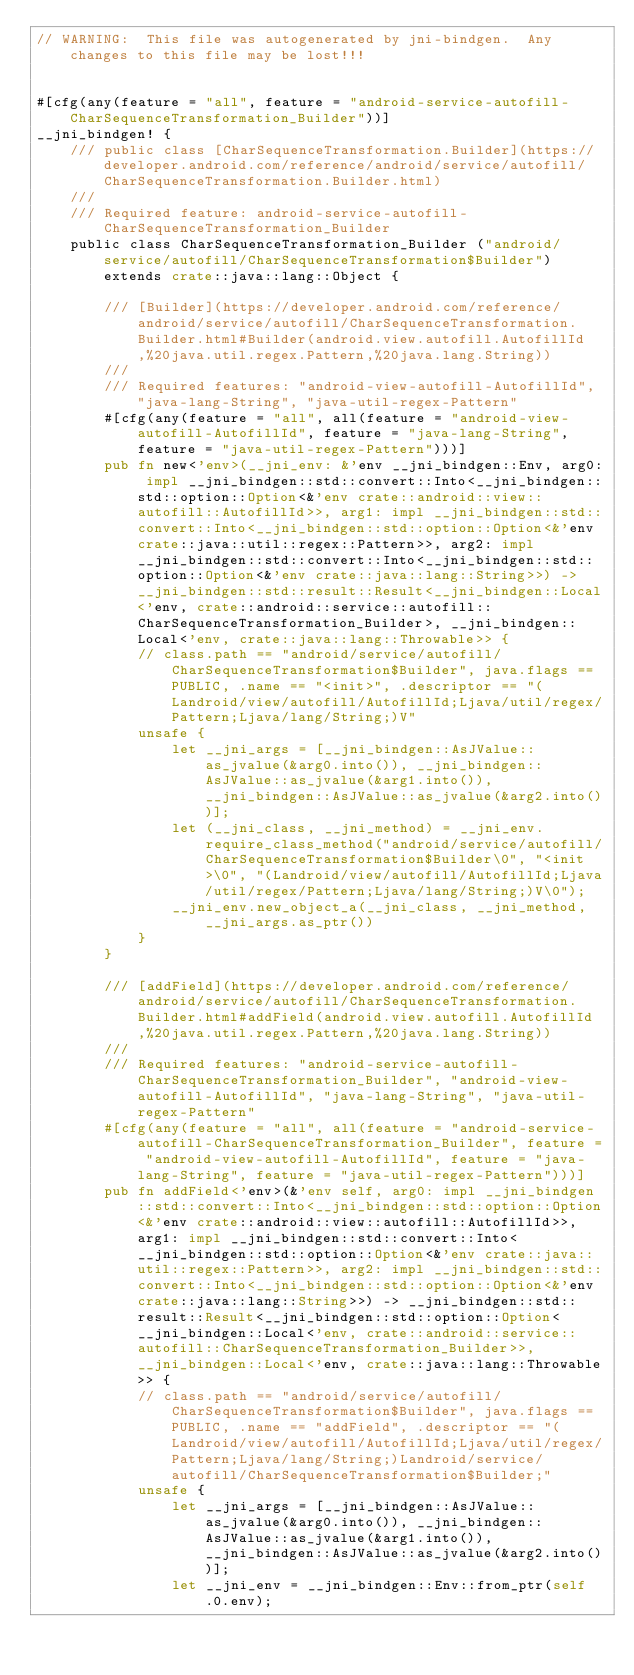<code> <loc_0><loc_0><loc_500><loc_500><_Rust_>// WARNING:  This file was autogenerated by jni-bindgen.  Any changes to this file may be lost!!!


#[cfg(any(feature = "all", feature = "android-service-autofill-CharSequenceTransformation_Builder"))]
__jni_bindgen! {
    /// public class [CharSequenceTransformation.Builder](https://developer.android.com/reference/android/service/autofill/CharSequenceTransformation.Builder.html)
    ///
    /// Required feature: android-service-autofill-CharSequenceTransformation_Builder
    public class CharSequenceTransformation_Builder ("android/service/autofill/CharSequenceTransformation$Builder") extends crate::java::lang::Object {

        /// [Builder](https://developer.android.com/reference/android/service/autofill/CharSequenceTransformation.Builder.html#Builder(android.view.autofill.AutofillId,%20java.util.regex.Pattern,%20java.lang.String))
        ///
        /// Required features: "android-view-autofill-AutofillId", "java-lang-String", "java-util-regex-Pattern"
        #[cfg(any(feature = "all", all(feature = "android-view-autofill-AutofillId", feature = "java-lang-String", feature = "java-util-regex-Pattern")))]
        pub fn new<'env>(__jni_env: &'env __jni_bindgen::Env, arg0: impl __jni_bindgen::std::convert::Into<__jni_bindgen::std::option::Option<&'env crate::android::view::autofill::AutofillId>>, arg1: impl __jni_bindgen::std::convert::Into<__jni_bindgen::std::option::Option<&'env crate::java::util::regex::Pattern>>, arg2: impl __jni_bindgen::std::convert::Into<__jni_bindgen::std::option::Option<&'env crate::java::lang::String>>) -> __jni_bindgen::std::result::Result<__jni_bindgen::Local<'env, crate::android::service::autofill::CharSequenceTransformation_Builder>, __jni_bindgen::Local<'env, crate::java::lang::Throwable>> {
            // class.path == "android/service/autofill/CharSequenceTransformation$Builder", java.flags == PUBLIC, .name == "<init>", .descriptor == "(Landroid/view/autofill/AutofillId;Ljava/util/regex/Pattern;Ljava/lang/String;)V"
            unsafe {
                let __jni_args = [__jni_bindgen::AsJValue::as_jvalue(&arg0.into()), __jni_bindgen::AsJValue::as_jvalue(&arg1.into()), __jni_bindgen::AsJValue::as_jvalue(&arg2.into())];
                let (__jni_class, __jni_method) = __jni_env.require_class_method("android/service/autofill/CharSequenceTransformation$Builder\0", "<init>\0", "(Landroid/view/autofill/AutofillId;Ljava/util/regex/Pattern;Ljava/lang/String;)V\0");
                __jni_env.new_object_a(__jni_class, __jni_method, __jni_args.as_ptr())
            }
        }

        /// [addField](https://developer.android.com/reference/android/service/autofill/CharSequenceTransformation.Builder.html#addField(android.view.autofill.AutofillId,%20java.util.regex.Pattern,%20java.lang.String))
        ///
        /// Required features: "android-service-autofill-CharSequenceTransformation_Builder", "android-view-autofill-AutofillId", "java-lang-String", "java-util-regex-Pattern"
        #[cfg(any(feature = "all", all(feature = "android-service-autofill-CharSequenceTransformation_Builder", feature = "android-view-autofill-AutofillId", feature = "java-lang-String", feature = "java-util-regex-Pattern")))]
        pub fn addField<'env>(&'env self, arg0: impl __jni_bindgen::std::convert::Into<__jni_bindgen::std::option::Option<&'env crate::android::view::autofill::AutofillId>>, arg1: impl __jni_bindgen::std::convert::Into<__jni_bindgen::std::option::Option<&'env crate::java::util::regex::Pattern>>, arg2: impl __jni_bindgen::std::convert::Into<__jni_bindgen::std::option::Option<&'env crate::java::lang::String>>) -> __jni_bindgen::std::result::Result<__jni_bindgen::std::option::Option<__jni_bindgen::Local<'env, crate::android::service::autofill::CharSequenceTransformation_Builder>>, __jni_bindgen::Local<'env, crate::java::lang::Throwable>> {
            // class.path == "android/service/autofill/CharSequenceTransformation$Builder", java.flags == PUBLIC, .name == "addField", .descriptor == "(Landroid/view/autofill/AutofillId;Ljava/util/regex/Pattern;Ljava/lang/String;)Landroid/service/autofill/CharSequenceTransformation$Builder;"
            unsafe {
                let __jni_args = [__jni_bindgen::AsJValue::as_jvalue(&arg0.into()), __jni_bindgen::AsJValue::as_jvalue(&arg1.into()), __jni_bindgen::AsJValue::as_jvalue(&arg2.into())];
                let __jni_env = __jni_bindgen::Env::from_ptr(self.0.env);</code> 